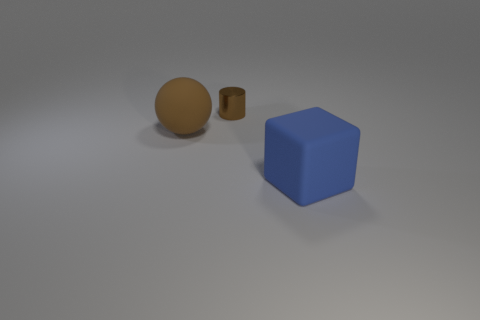Add 3 green metal balls. How many objects exist? 6 Subtract all cylinders. How many objects are left? 2 Subtract all tiny blue blocks. Subtract all blue things. How many objects are left? 2 Add 1 small metallic things. How many small metallic things are left? 2 Add 1 large brown rubber things. How many large brown rubber things exist? 2 Subtract 0 gray cylinders. How many objects are left? 3 